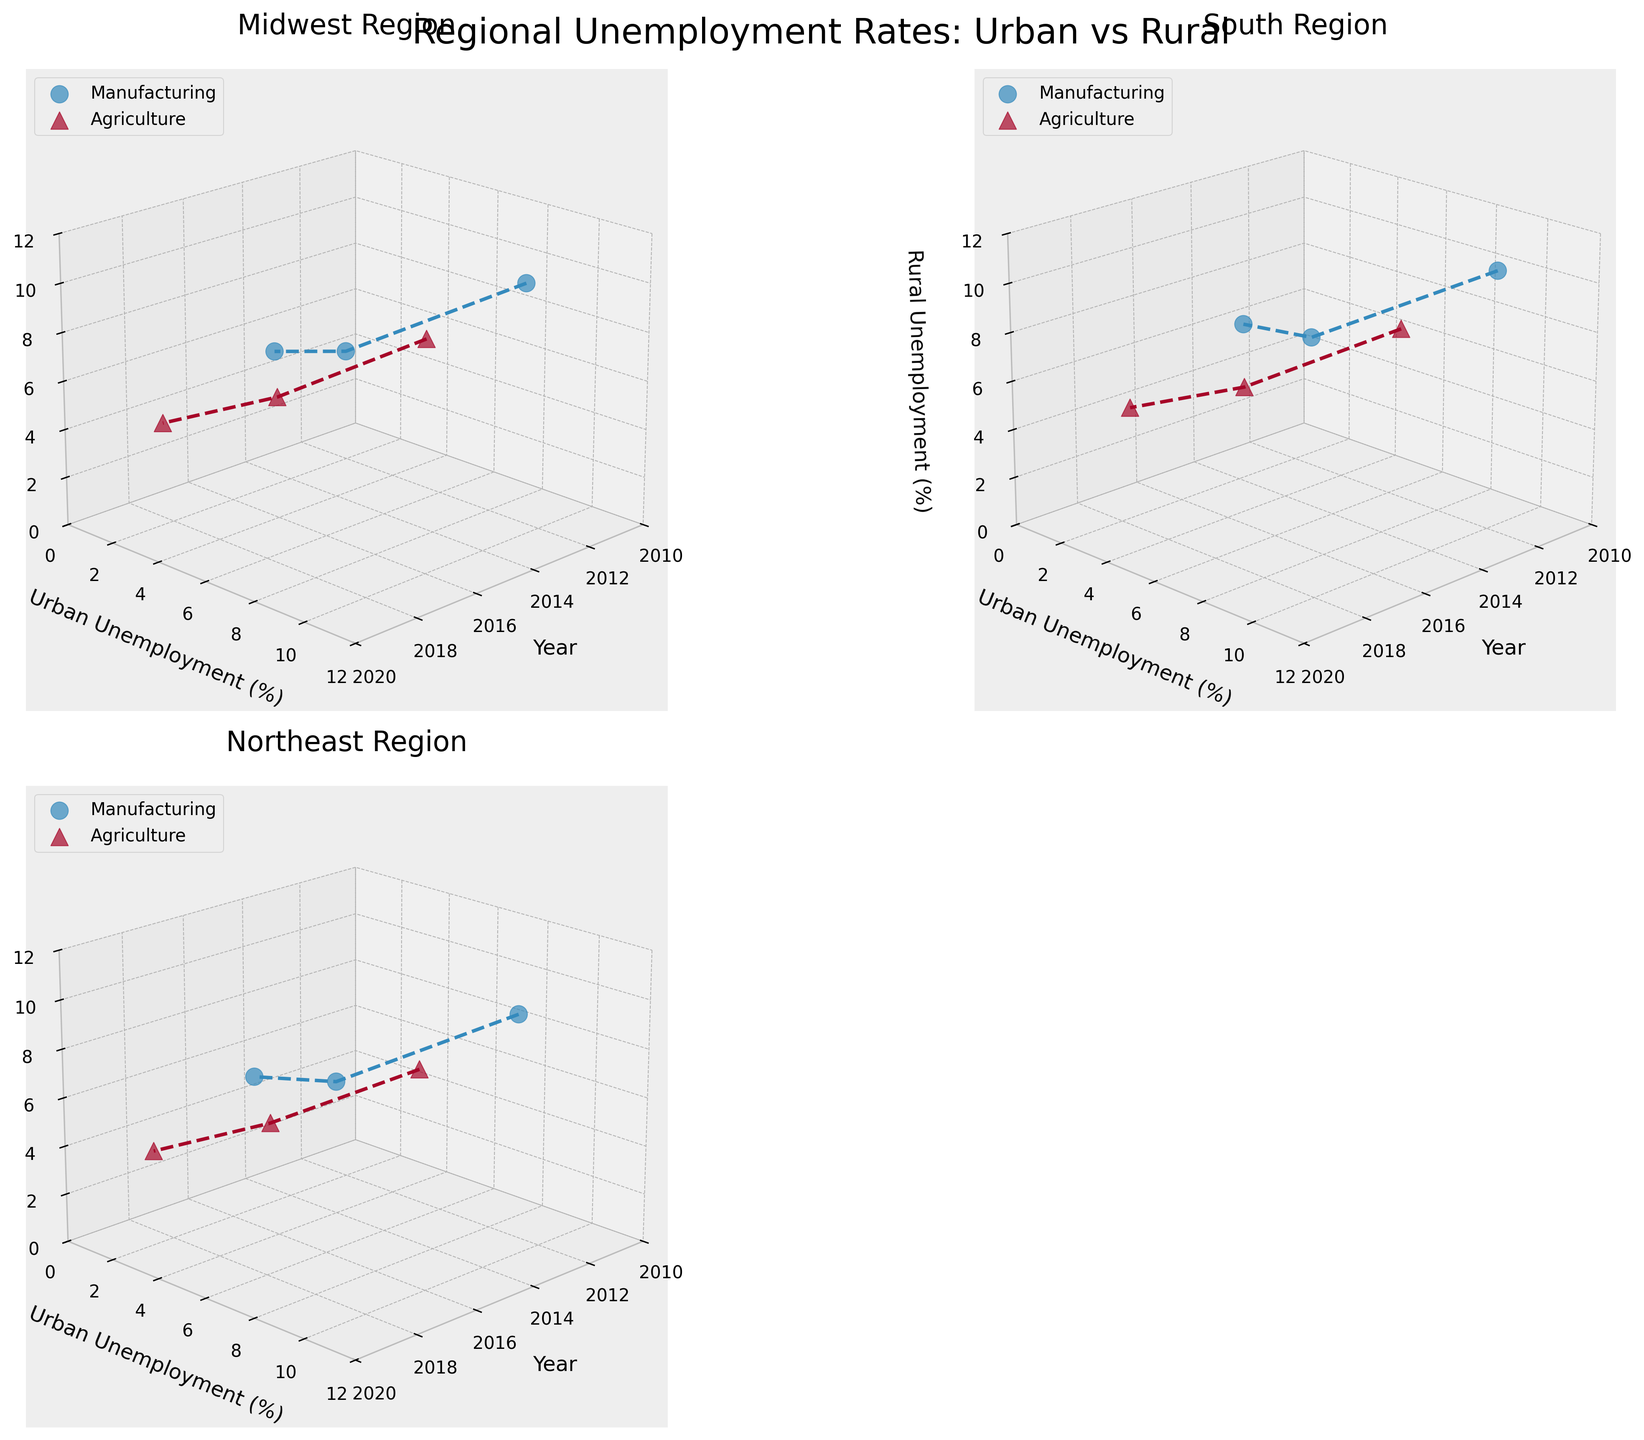What is the title of the figure? The title is typically found at the top of the figure. The overall title in this plot is "Regional Unemployment Rates: Urban vs Rural".
Answer: Regional Unemployment Rates: Urban vs Rural Which region has the highest rural unemployment rate for the manufacturing industry in 2020? By examining all subplots, focus on the data points for the year 2020, specifically for the manufacturing industry. The South region has the highest value at 11.5%.
Answer: South How does the urban unemployment rate for agriculture in the Northeast region change from 2010 to 2020? Look at the subplot for the Northeast region and track the agriculture industry's urban unemployment data points from 2010 to 2020. It increases from 2.8% in 2010 to 3.9% in 2020.
Answer: It increases What is the difference between urban and rural unemployment rates for manufacturing in the Midwest region in 2010? Locate the 2010 data points for manufacturing in the Midwest region subplot. Subtract the urban rate (7.2%) from the rural rate (8.5%) to get the difference. The difference is 1.3%.
Answer: 1.3% Which industry showed a more significant shift in rural unemployment rates from 2010 to 2020 in the South region? Compare the shift in rural unemployment rates over the years for manufacturing and agriculture within the South region subplot. Manufacturing changes from 9.3% to 11.5%, and agriculture changes from 5.6% to 6.7%. The manufacturing industry shows a larger shift.
Answer: Manufacturing In which year did the Midwest region see the lowest urban unemployment rate for agriculture? In the Midwest subplot, compare the agriculture urban unemployment rates across the years. The lowest rate is in 2015, at 2.7%.
Answer: 2015 Are rural unemployment rates generally higher or lower than urban unemployment rates across all years and regions? By inspecting all subplots for both industries across the years, it's apparent that rural unemployment rates are consistently higher than urban unemployment rates.
Answer: Higher How did the unemployment rates for the manufacturing industry in the Northeast region change from 2015 to 2020? Focus on the manufacturing data points in the Northeast subplot between these years. Urban unemployment increased from 5.2% to 8.1%, and rural unemployment increased from 6.4% to 9.6%. Both urban and rural rates increased.
Answer: Both increased Which region reported the lowest rural unemployment rate for agriculture in 2020? Scan each region's subplot for the agriculture industry's rural unemployment in 2020. The Northeast region has the lowest rate at 5.2%.
Answer: Northeast 